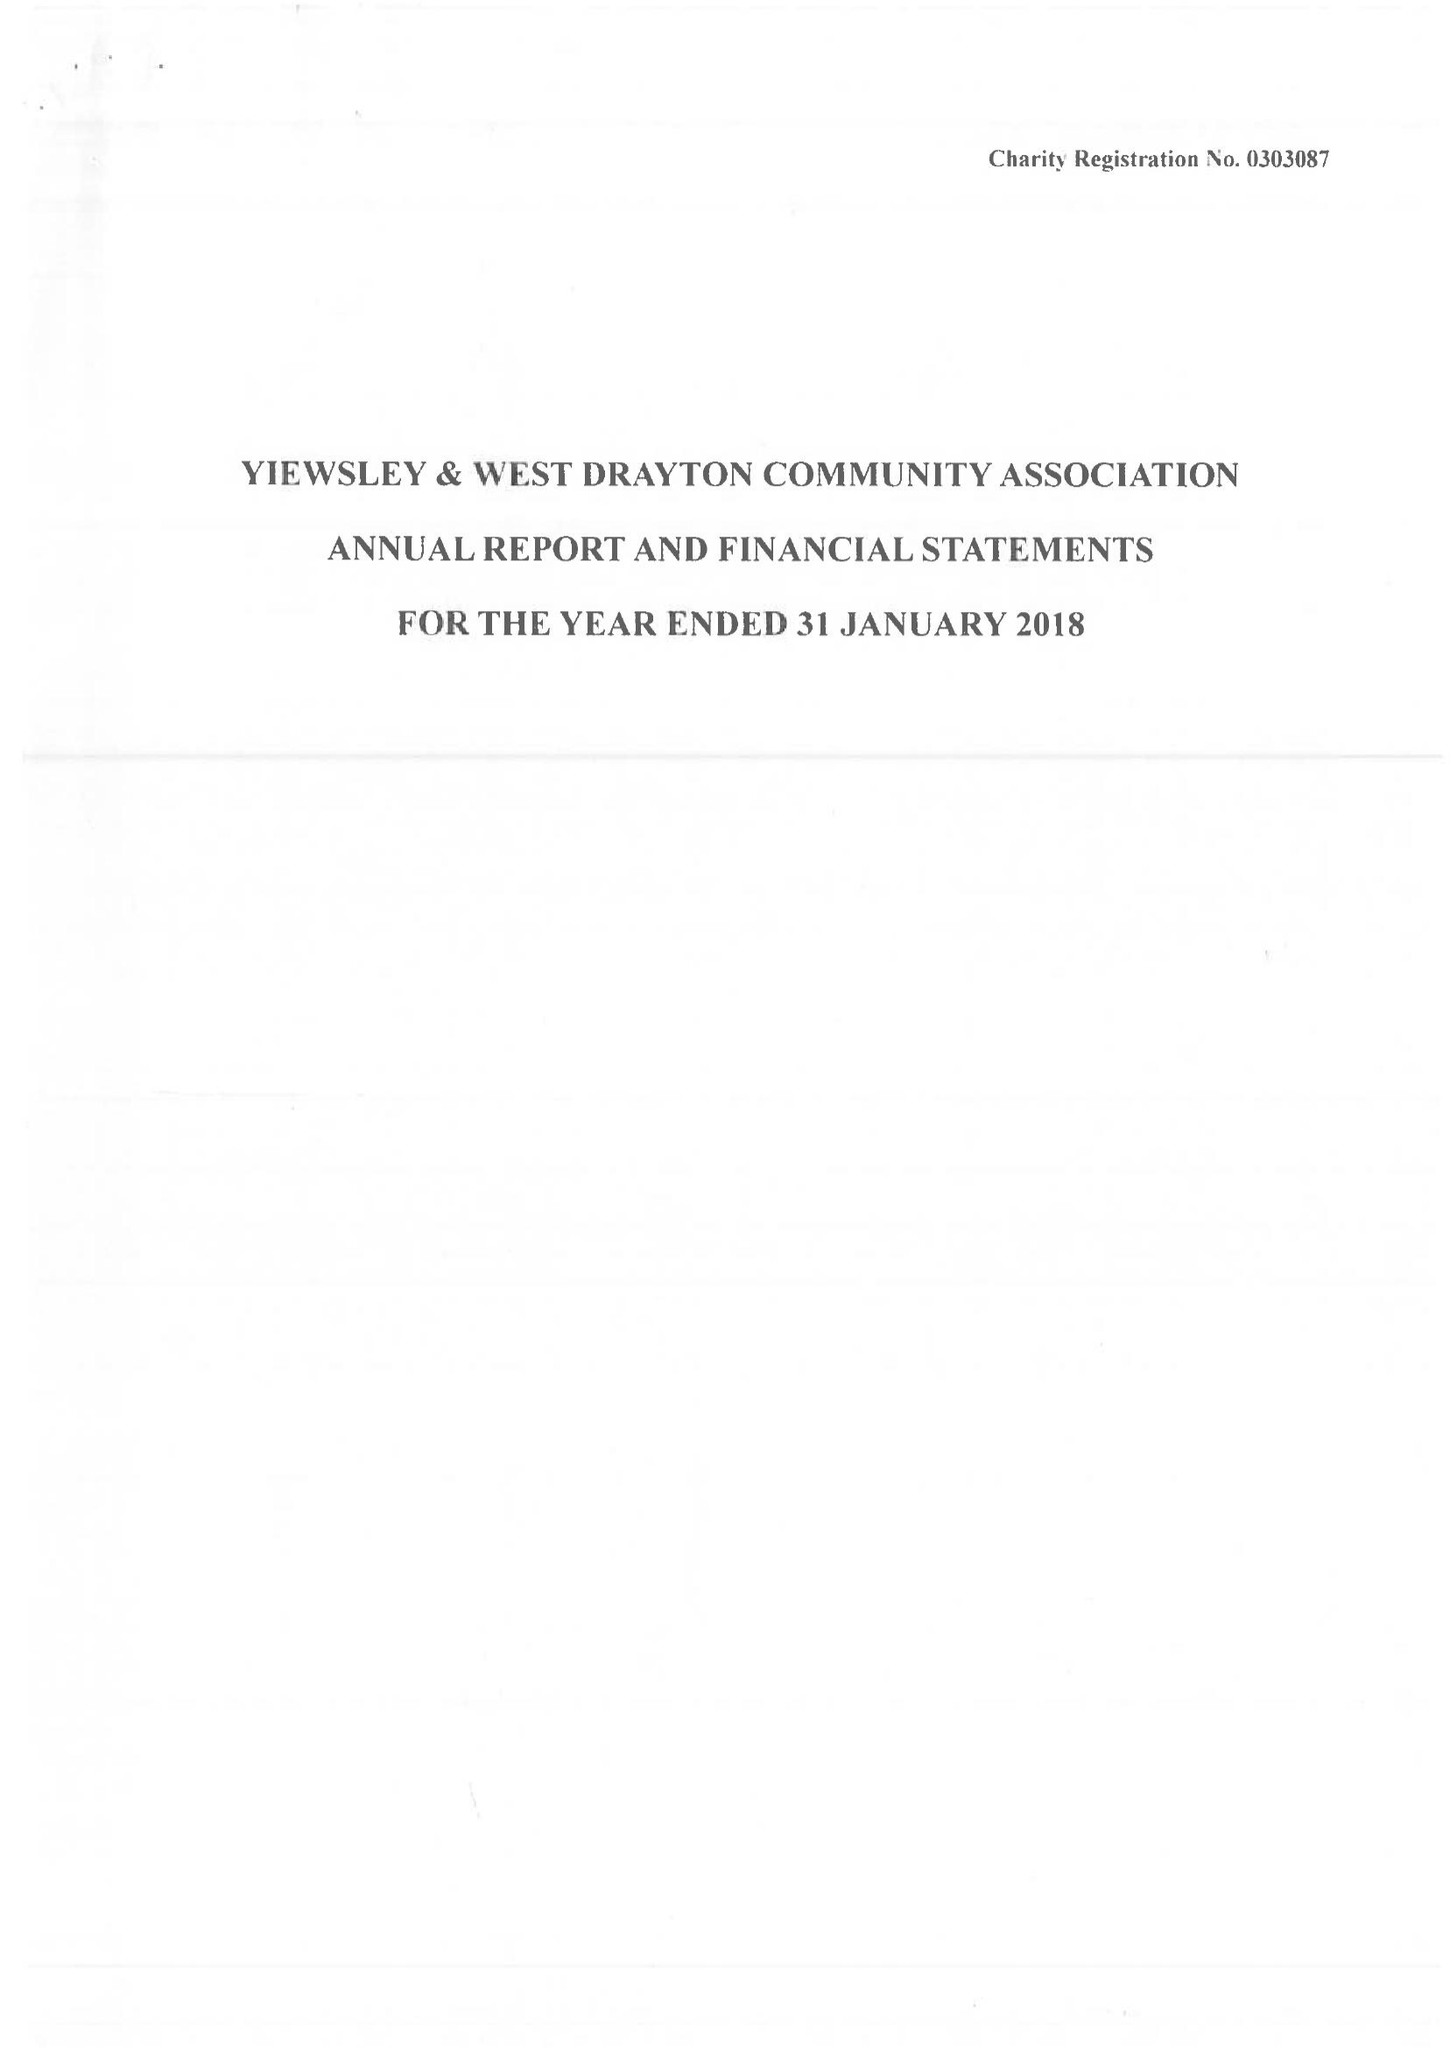What is the value for the address__street_line?
Answer the question using a single word or phrase. 228 HARMONDSWORTH ROAD 